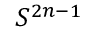<formula> <loc_0><loc_0><loc_500><loc_500>S ^ { 2 n - 1 }</formula> 